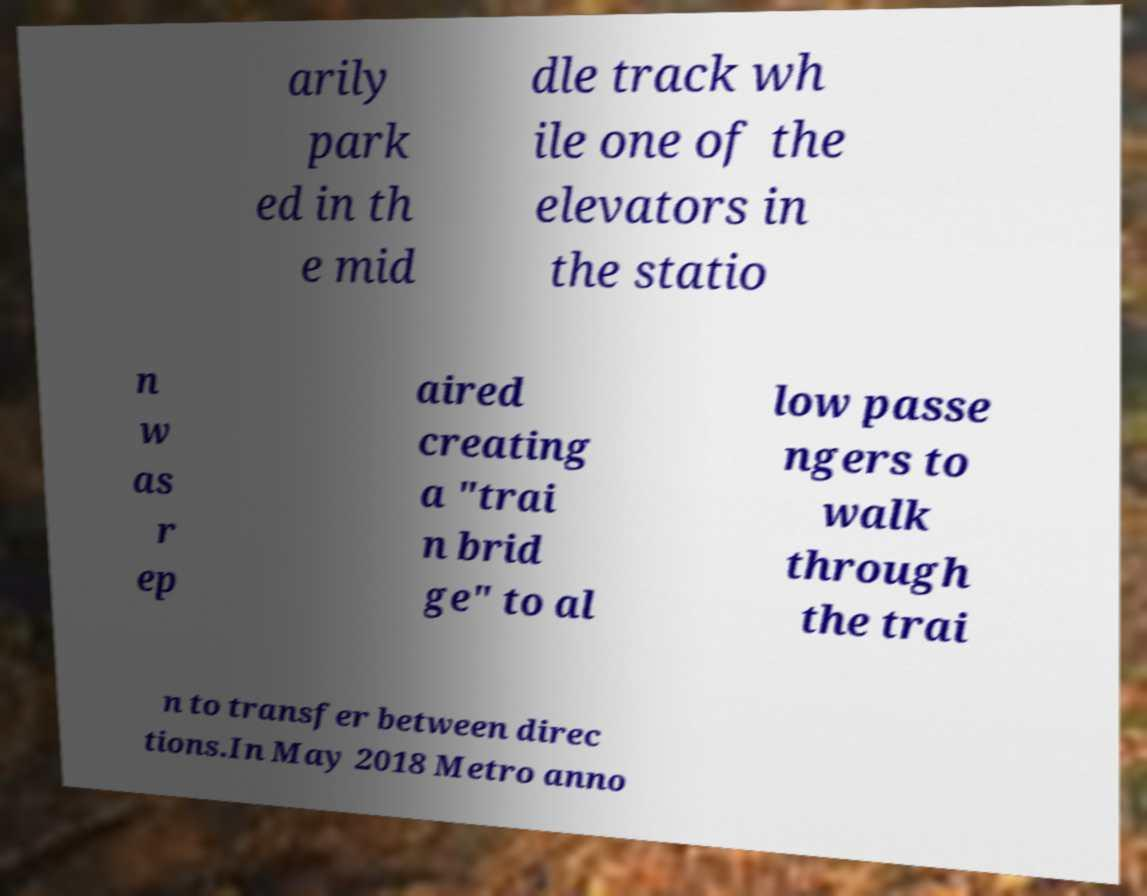For documentation purposes, I need the text within this image transcribed. Could you provide that? arily park ed in th e mid dle track wh ile one of the elevators in the statio n w as r ep aired creating a "trai n brid ge" to al low passe ngers to walk through the trai n to transfer between direc tions.In May 2018 Metro anno 